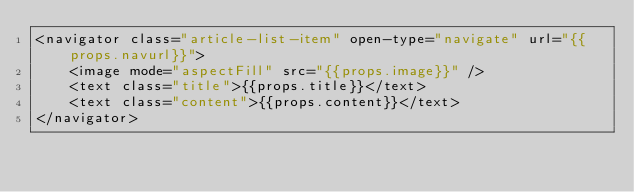<code> <loc_0><loc_0><loc_500><loc_500><_XML_><navigator class="article-list-item" open-type="navigate" url="{{props.navurl}}">
	<image mode="aspectFill" src="{{props.image}}" />
	<text class="title">{{props.title}}</text>
	<text class="content">{{props.content}}</text>
</navigator></code> 